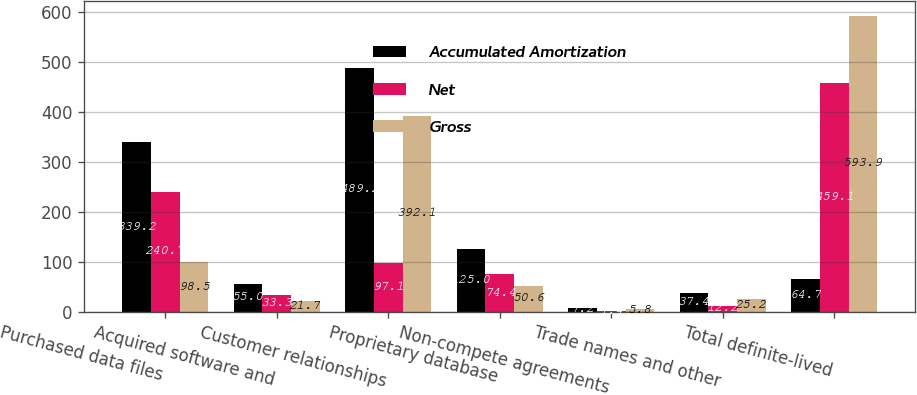Convert chart to OTSL. <chart><loc_0><loc_0><loc_500><loc_500><stacked_bar_chart><ecel><fcel>Purchased data files<fcel>Acquired software and<fcel>Customer relationships<fcel>Proprietary database<fcel>Non-compete agreements<fcel>Trade names and other<fcel>Total definite-lived<nl><fcel>Accumulated Amortization<fcel>339.2<fcel>55<fcel>489.2<fcel>125<fcel>7.2<fcel>37.4<fcel>64.7<nl><fcel>Net<fcel>240.7<fcel>33.3<fcel>97.1<fcel>74.4<fcel>1.4<fcel>12.2<fcel>459.1<nl><fcel>Gross<fcel>98.5<fcel>21.7<fcel>392.1<fcel>50.6<fcel>5.8<fcel>25.2<fcel>593.9<nl></chart> 